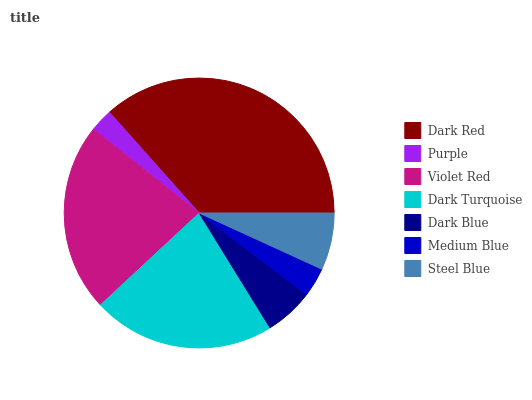Is Purple the minimum?
Answer yes or no. Yes. Is Dark Red the maximum?
Answer yes or no. Yes. Is Violet Red the minimum?
Answer yes or no. No. Is Violet Red the maximum?
Answer yes or no. No. Is Violet Red greater than Purple?
Answer yes or no. Yes. Is Purple less than Violet Red?
Answer yes or no. Yes. Is Purple greater than Violet Red?
Answer yes or no. No. Is Violet Red less than Purple?
Answer yes or no. No. Is Steel Blue the high median?
Answer yes or no. Yes. Is Steel Blue the low median?
Answer yes or no. Yes. Is Medium Blue the high median?
Answer yes or no. No. Is Medium Blue the low median?
Answer yes or no. No. 